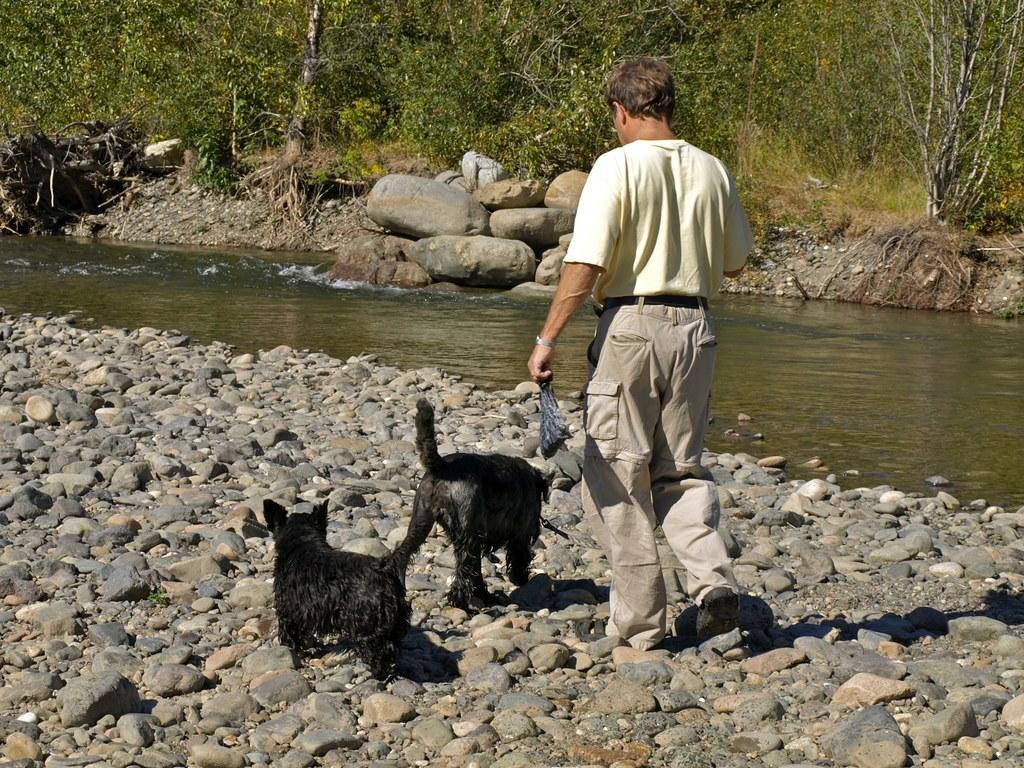Please provide a concise description of this image. In the image there is a man walking on stone pebbles and there are two black puppies in front of him. Beside him there is a lake flowing and the total end there are trees. 